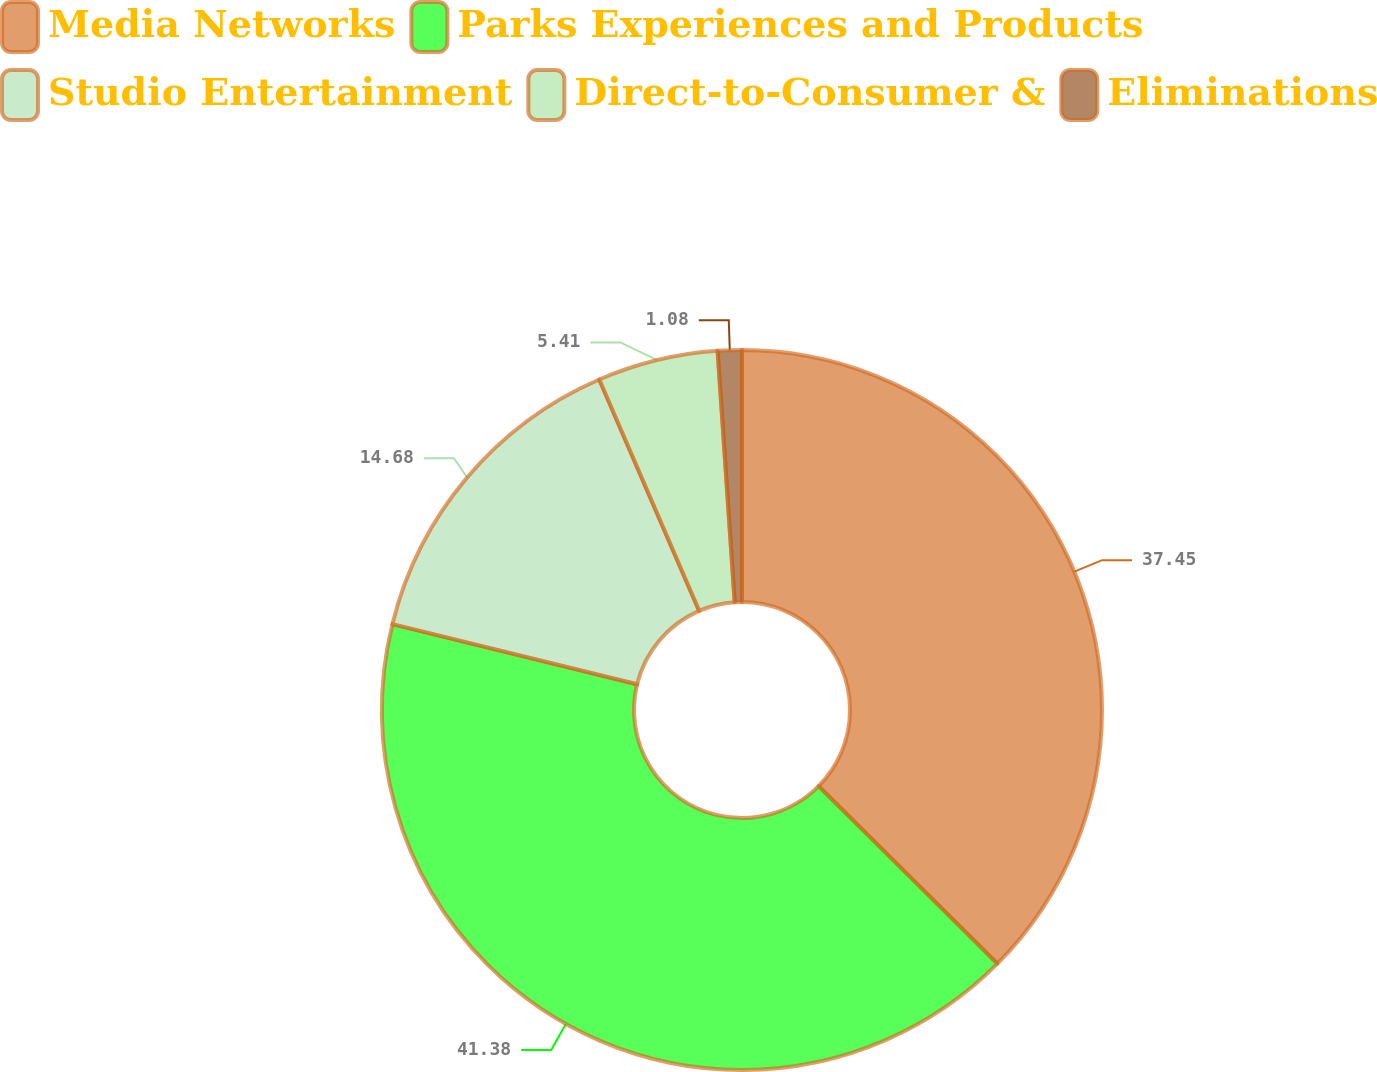Convert chart to OTSL. <chart><loc_0><loc_0><loc_500><loc_500><pie_chart><fcel>Media Networks<fcel>Parks Experiences and Products<fcel>Studio Entertainment<fcel>Direct-to-Consumer &<fcel>Eliminations<nl><fcel>37.45%<fcel>41.39%<fcel>14.68%<fcel>5.41%<fcel>1.08%<nl></chart> 